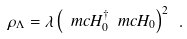Convert formula to latex. <formula><loc_0><loc_0><loc_500><loc_500>\rho _ { \Lambda } = \lambda \left ( \ m c H _ { 0 } ^ { \dagger } \ m c H _ { 0 } \right ) ^ { 2 } \ .</formula> 